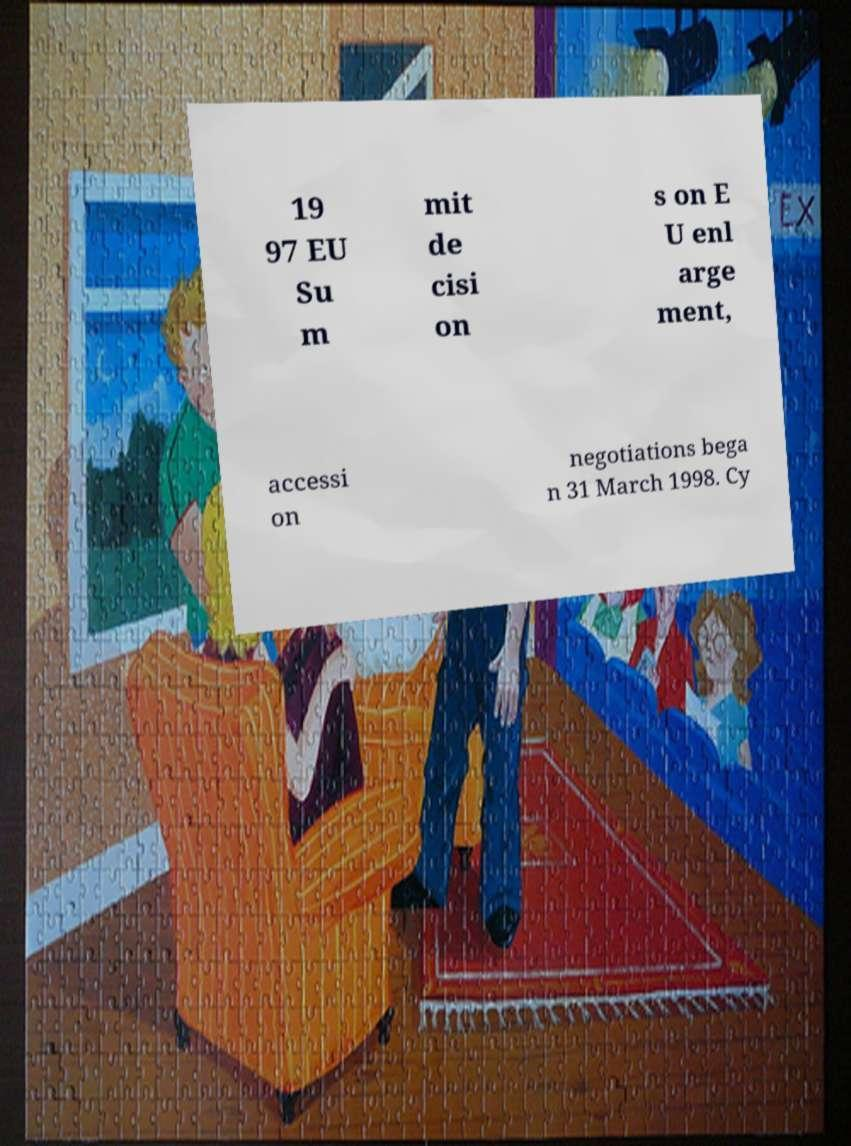Please identify and transcribe the text found in this image. 19 97 EU Su m mit de cisi on s on E U enl arge ment, accessi on negotiations bega n 31 March 1998. Cy 